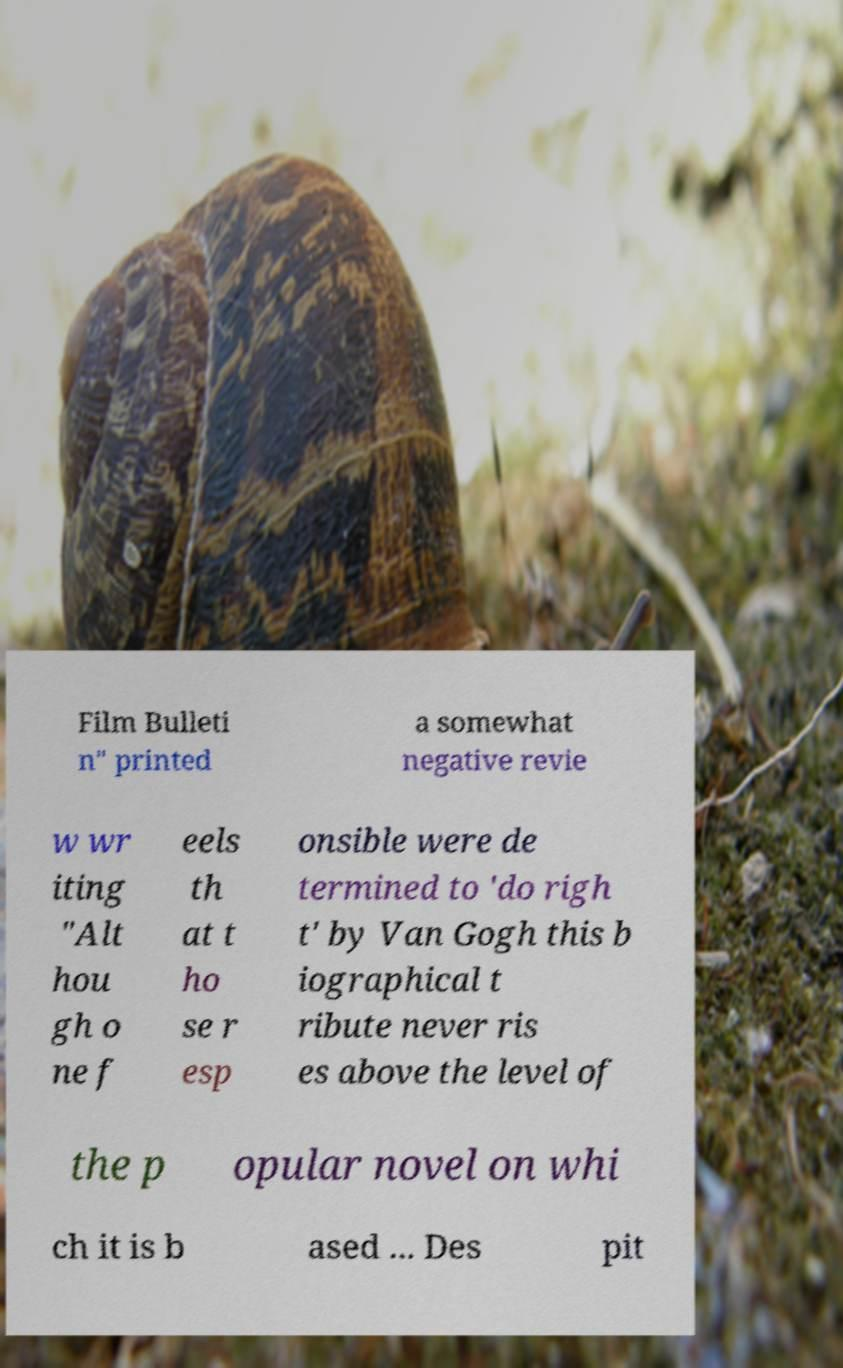Can you accurately transcribe the text from the provided image for me? Film Bulleti n" printed a somewhat negative revie w wr iting "Alt hou gh o ne f eels th at t ho se r esp onsible were de termined to 'do righ t' by Van Gogh this b iographical t ribute never ris es above the level of the p opular novel on whi ch it is b ased ... Des pit 